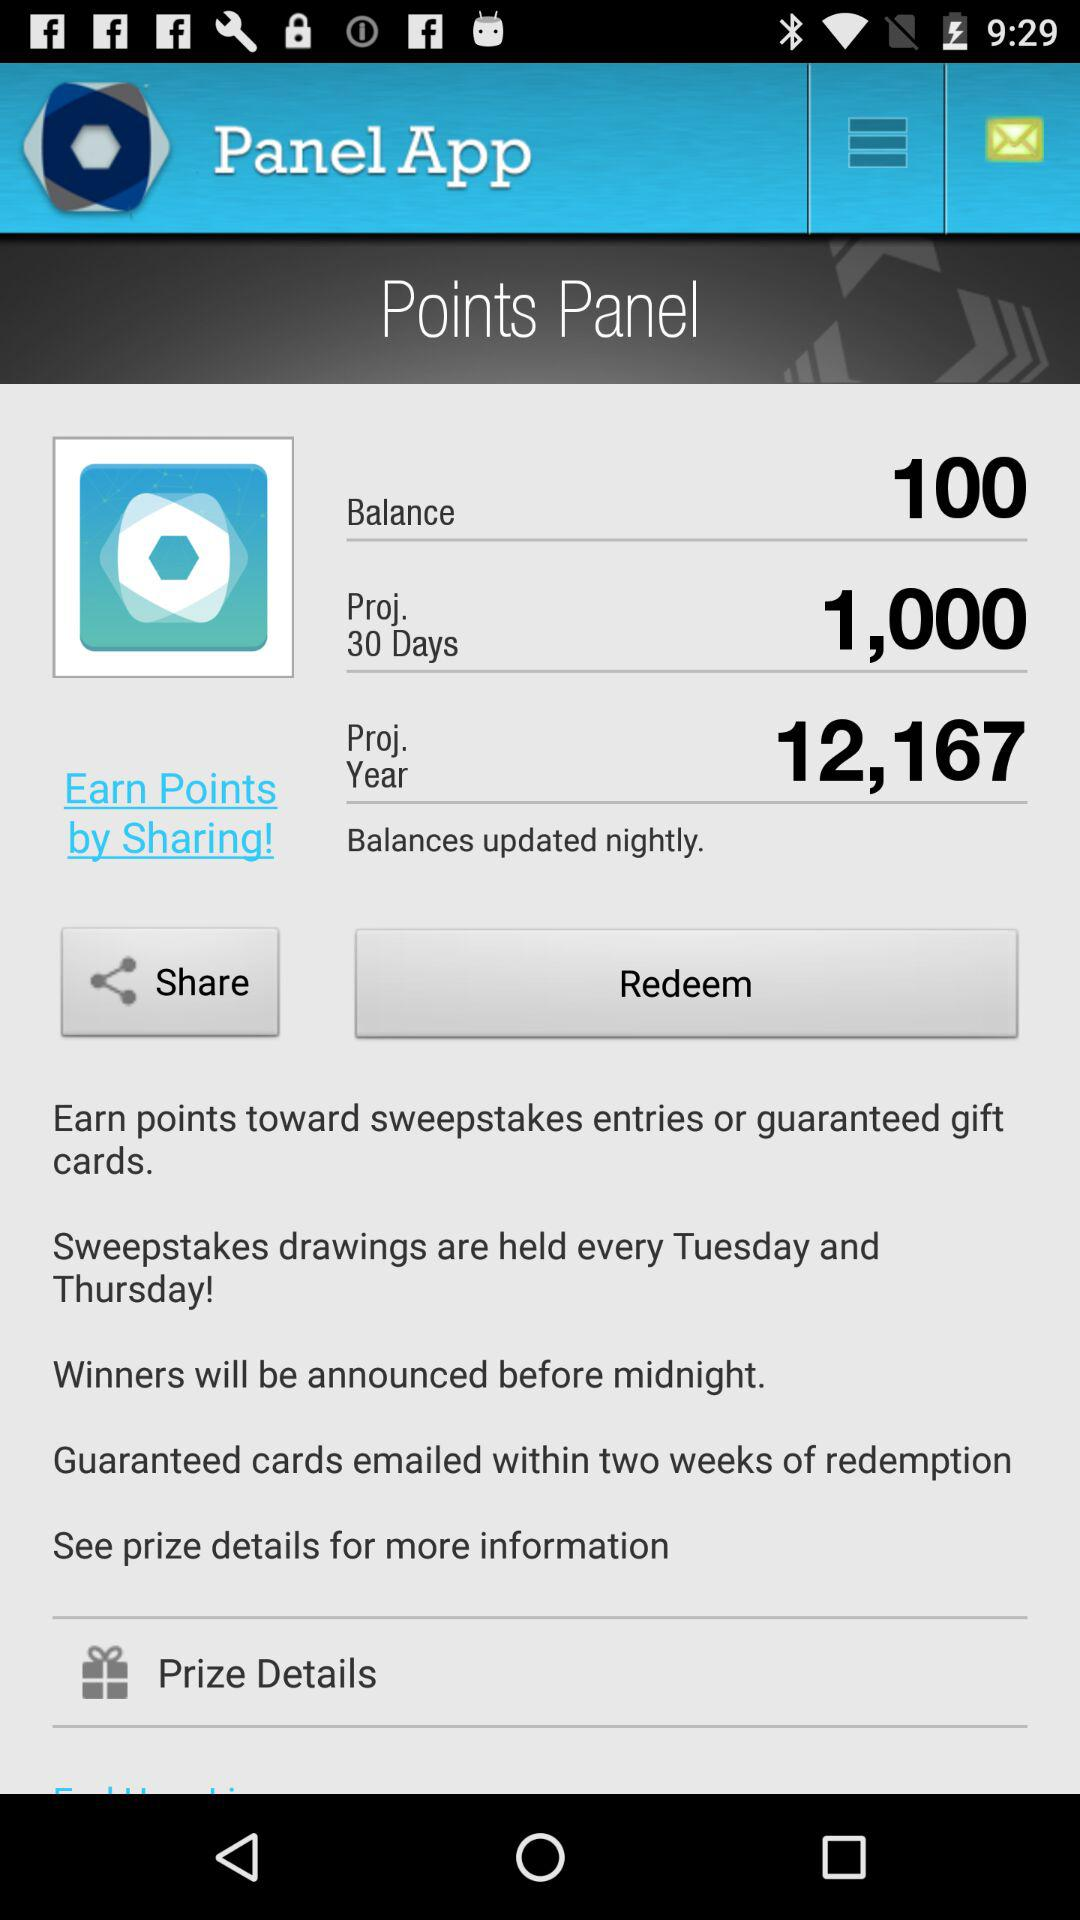How can we earn the points? You can earn the points by sharing and entering sweepstakes entries or guaranteed gift cards. 